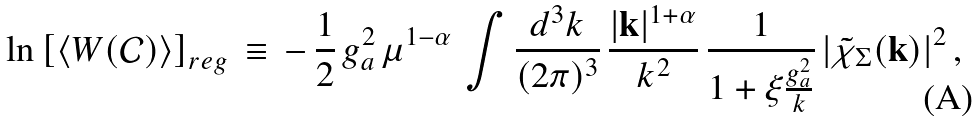Convert formula to latex. <formula><loc_0><loc_0><loc_500><loc_500>\ln \left [ \langle W ( { \mathcal { C } } ) \rangle \right ] _ { r e g } \, \equiv \, - \, \frac { 1 } { 2 } \, g _ { a } ^ { 2 } \, \mu ^ { 1 - \alpha } \, \int \frac { d ^ { 3 } k } { ( 2 \pi ) ^ { 3 } } \, \frac { | { \mathbf k } | ^ { 1 + \alpha } } { k ^ { 2 } } \, \frac { 1 } { 1 + \xi \frac { g _ { a } ^ { 2 } } { k } } \, | { \tilde { \chi } } _ { \Sigma } ( { \mathbf k } ) | ^ { 2 } \, ,</formula> 